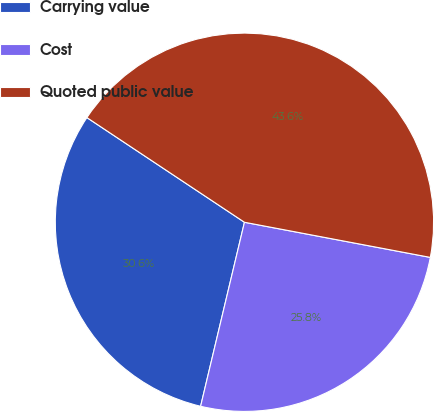<chart> <loc_0><loc_0><loc_500><loc_500><pie_chart><fcel>Carrying value<fcel>Cost<fcel>Quoted public value<nl><fcel>30.61%<fcel>25.75%<fcel>43.64%<nl></chart> 